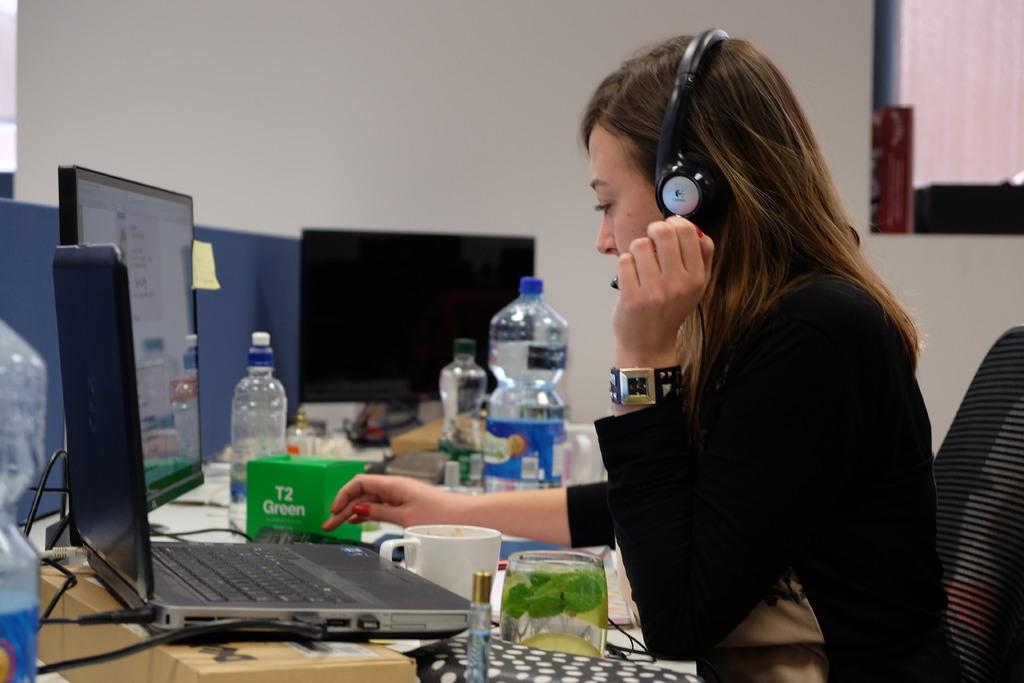<image>
Describe the image concisely. A woman types on her laptop next to a green box that says T2 Green. 